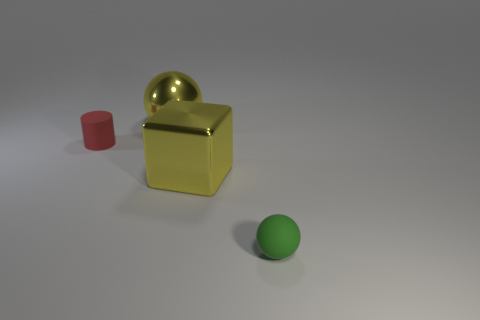There is a object that is both on the right side of the cylinder and behind the big shiny block; what size is it?
Offer a terse response. Large. There is a metal object that is the same color as the big sphere; what shape is it?
Offer a very short reply. Cube. The large metal sphere is what color?
Provide a short and direct response. Yellow. There is a rubber cylinder behind the small green matte object; what size is it?
Make the answer very short. Small. How many green things are right of the yellow metallic object to the left of the yellow object on the right side of the yellow metal ball?
Your answer should be compact. 1. There is a matte object that is in front of the cylinder that is in front of the large sphere; what is its color?
Your answer should be very brief. Green. Is there a brown matte thing of the same size as the yellow cube?
Make the answer very short. No. The yellow cube in front of the large yellow shiny object behind the metallic thing right of the big yellow metallic sphere is made of what material?
Your response must be concise. Metal. How many large yellow shiny blocks are behind the big metallic thing that is on the right side of the metallic ball?
Your answer should be very brief. 0. There is a rubber object to the left of the matte sphere; is its size the same as the small green sphere?
Provide a short and direct response. Yes. 